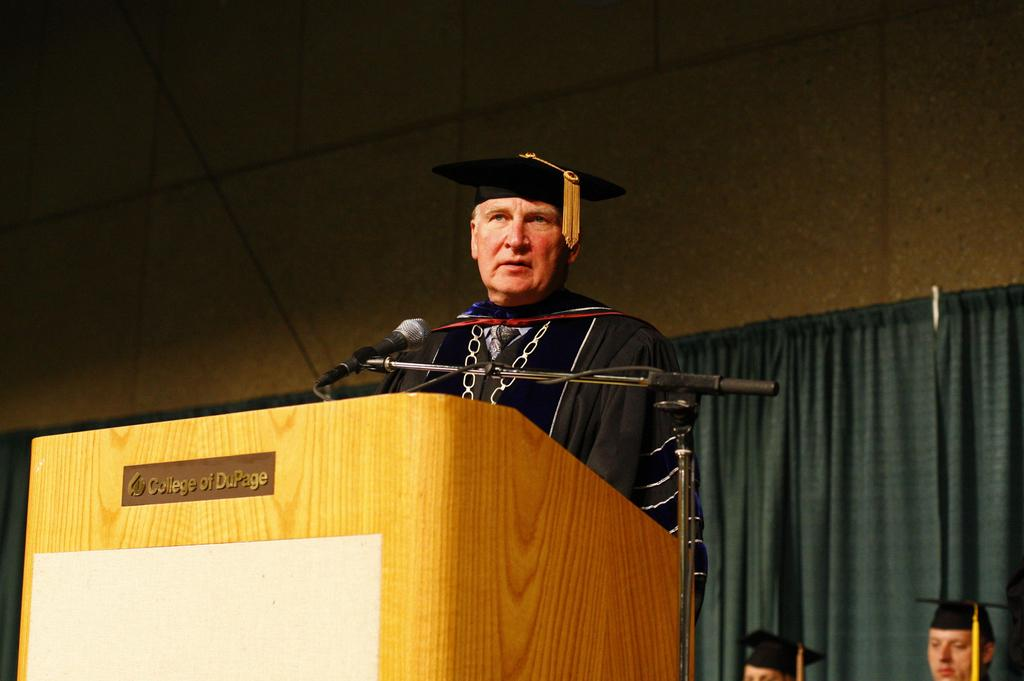What type of window treatment is visible in the image? There are curtains in the image. What type of structure can be seen in the background? There is a wall in the image. How many people are present in the image? There are three people in the image. Can you describe the appearance of one of the people? One of the people is a man wearing a black dress. What object is in front of the man? There is a mic in front of the man. What type of comb is the man using to style his hair in the image? There is no comb visible in the image, and the man's hair is not being styled. What type of argument is the man making in front of the mic in the image? There is no argument present in the image; the man is simply standing in front of the mic. 